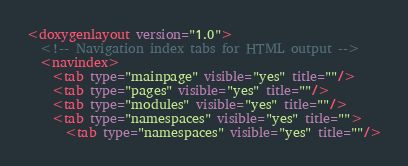<code> <loc_0><loc_0><loc_500><loc_500><_XML_><doxygenlayout version="1.0">
  <!-- Navigation index tabs for HTML output -->
  <navindex>
    <tab type="mainpage" visible="yes" title=""/>
    <tab type="pages" visible="yes" title=""/>
    <tab type="modules" visible="yes" title=""/>
    <tab type="namespaces" visible="yes" title="">
      <tab type="namespaces" visible="yes" title=""/></code> 